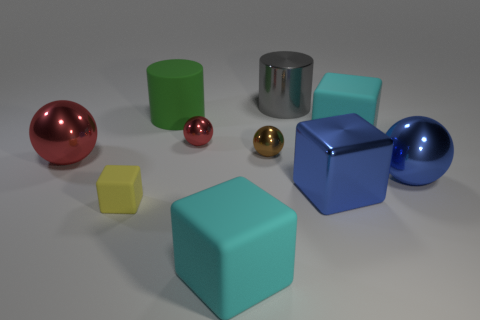How many cyan blocks must be subtracted to get 1 cyan blocks? 1 Subtract all big blue cubes. How many cubes are left? 3 Subtract 1 brown balls. How many objects are left? 9 Subtract all balls. How many objects are left? 6 Subtract 3 spheres. How many spheres are left? 1 Subtract all purple blocks. Subtract all blue cylinders. How many blocks are left? 4 Subtract all green cylinders. How many blue spheres are left? 1 Subtract all tiny green cubes. Subtract all large red metallic balls. How many objects are left? 9 Add 7 large cyan matte blocks. How many large cyan matte blocks are left? 9 Add 7 large cyan rubber balls. How many large cyan rubber balls exist? 7 